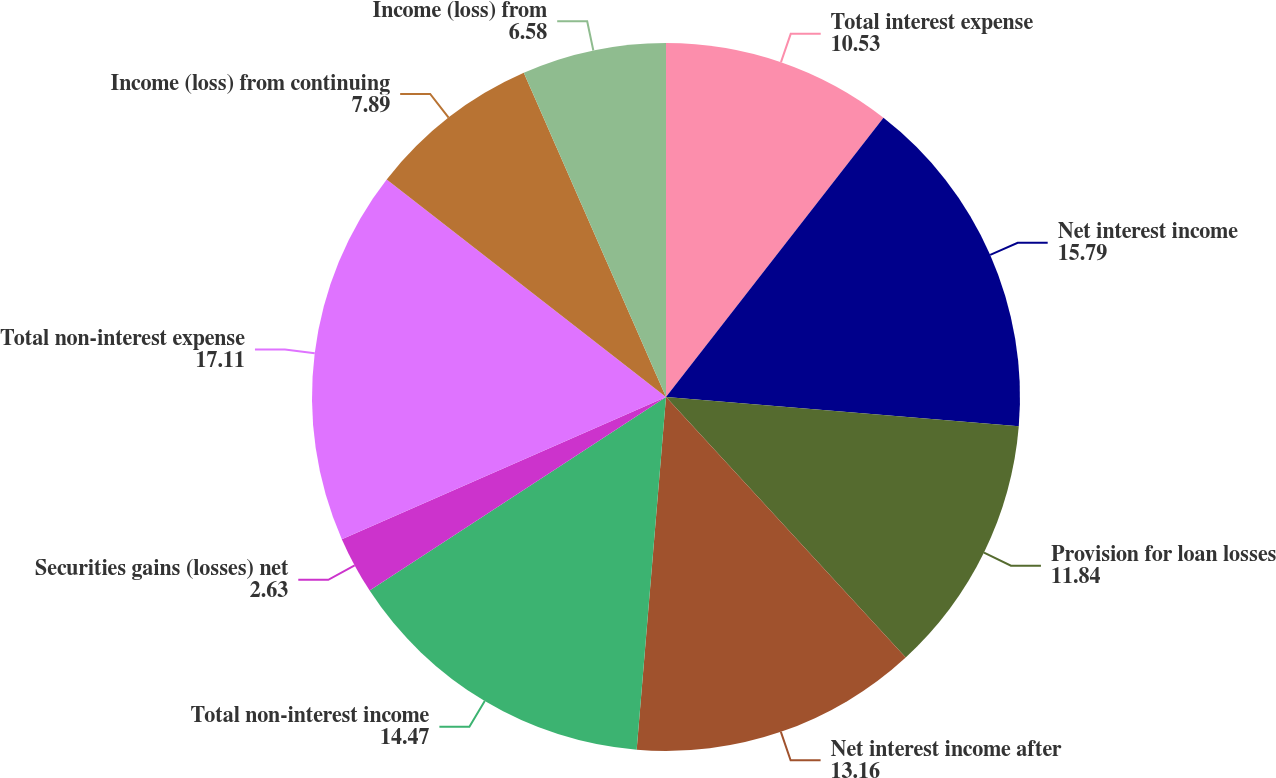Convert chart. <chart><loc_0><loc_0><loc_500><loc_500><pie_chart><fcel>Total interest expense<fcel>Net interest income<fcel>Provision for loan losses<fcel>Net interest income after<fcel>Total non-interest income<fcel>Securities gains (losses) net<fcel>Total non-interest expense<fcel>Income (loss) from continuing<fcel>Income (loss) from<nl><fcel>10.53%<fcel>15.79%<fcel>11.84%<fcel>13.16%<fcel>14.47%<fcel>2.63%<fcel>17.11%<fcel>7.89%<fcel>6.58%<nl></chart> 